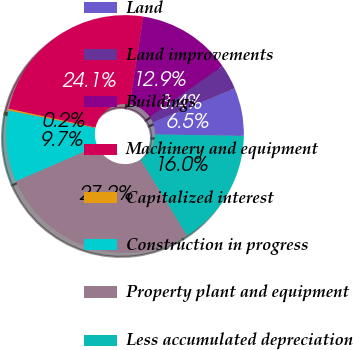<chart> <loc_0><loc_0><loc_500><loc_500><pie_chart><fcel>Land<fcel>Land improvements<fcel>Buildings<fcel>Machinery and equipment<fcel>Capitalized interest<fcel>Construction in progress<fcel>Property plant and equipment<fcel>Less accumulated depreciation<nl><fcel>6.54%<fcel>3.39%<fcel>12.85%<fcel>24.07%<fcel>0.24%<fcel>9.69%<fcel>27.22%<fcel>16.0%<nl></chart> 